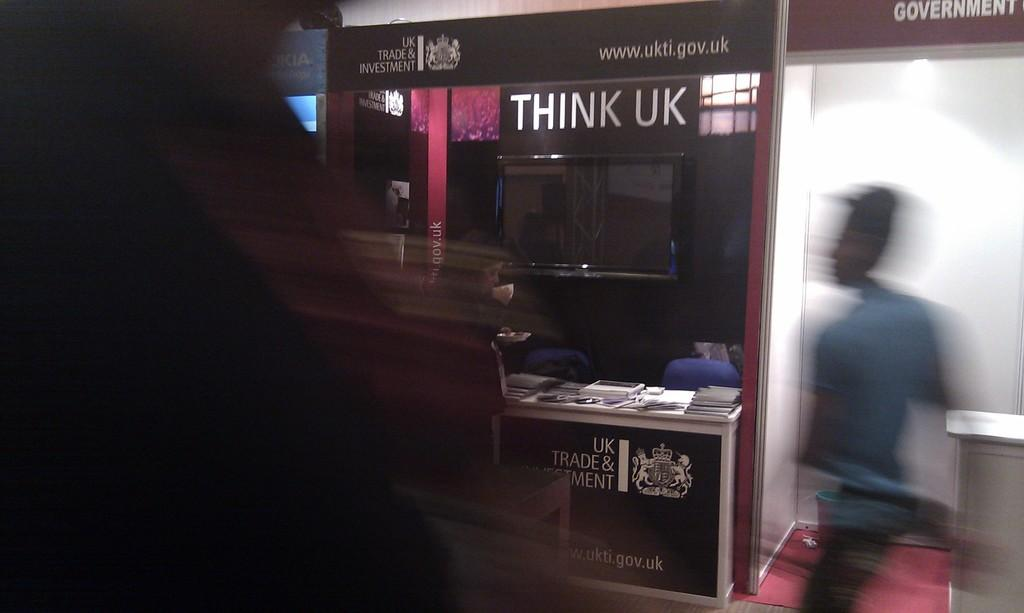<image>
Offer a succinct explanation of the picture presented. A man walking down a dark sidewalk with a stand on his right that reads, "THINK UK". 